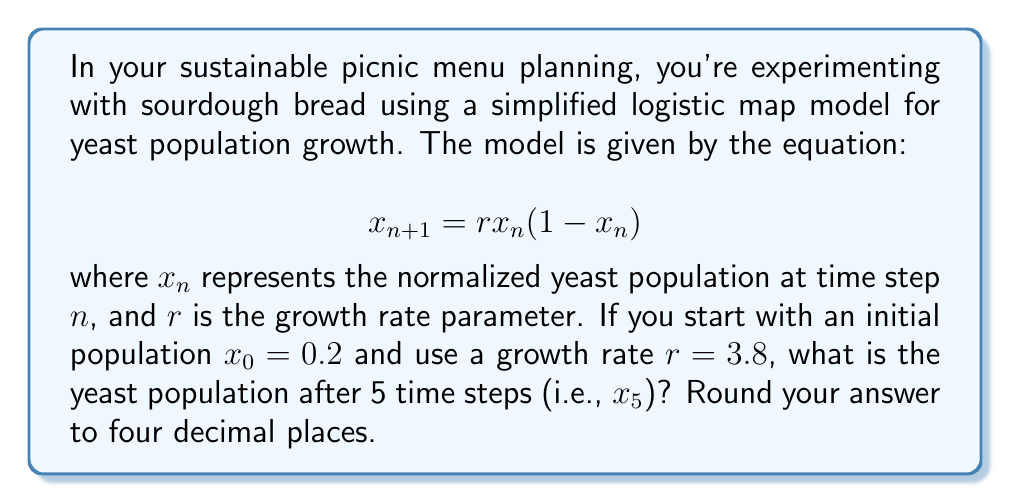Show me your answer to this math problem. To solve this problem, we need to iterate the logistic map equation for 5 time steps:

Step 1: Calculate $x_1$
$$x_1 = 3.8 \cdot 0.2(1-0.2) = 3.8 \cdot 0.2 \cdot 0.8 = 0.608$$

Step 2: Calculate $x_2$
$$x_2 = 3.8 \cdot 0.608(1-0.608) = 3.8 \cdot 0.608 \cdot 0.392 = 0.9066944$$

Step 3: Calculate $x_3$
$$x_3 = 3.8 \cdot 0.9066944(1-0.9066944) = 3.8 \cdot 0.9066944 \cdot 0.0933056 = 0.3214233$$

Step 4: Calculate $x_4$
$$x_4 = 3.8 \cdot 0.3214233(1-0.3214233) = 3.8 \cdot 0.3214233 \cdot 0.6785767 = 0.8307661$$

Step 5: Calculate $x_5$
$$x_5 = 3.8 \cdot 0.8307661(1-0.8307661) = 3.8 \cdot 0.8307661 \cdot 0.1692339 = 0.5348678$$

Step 6: Round to four decimal places
$$x_5 \approx 0.5349$$
Answer: 0.5349 